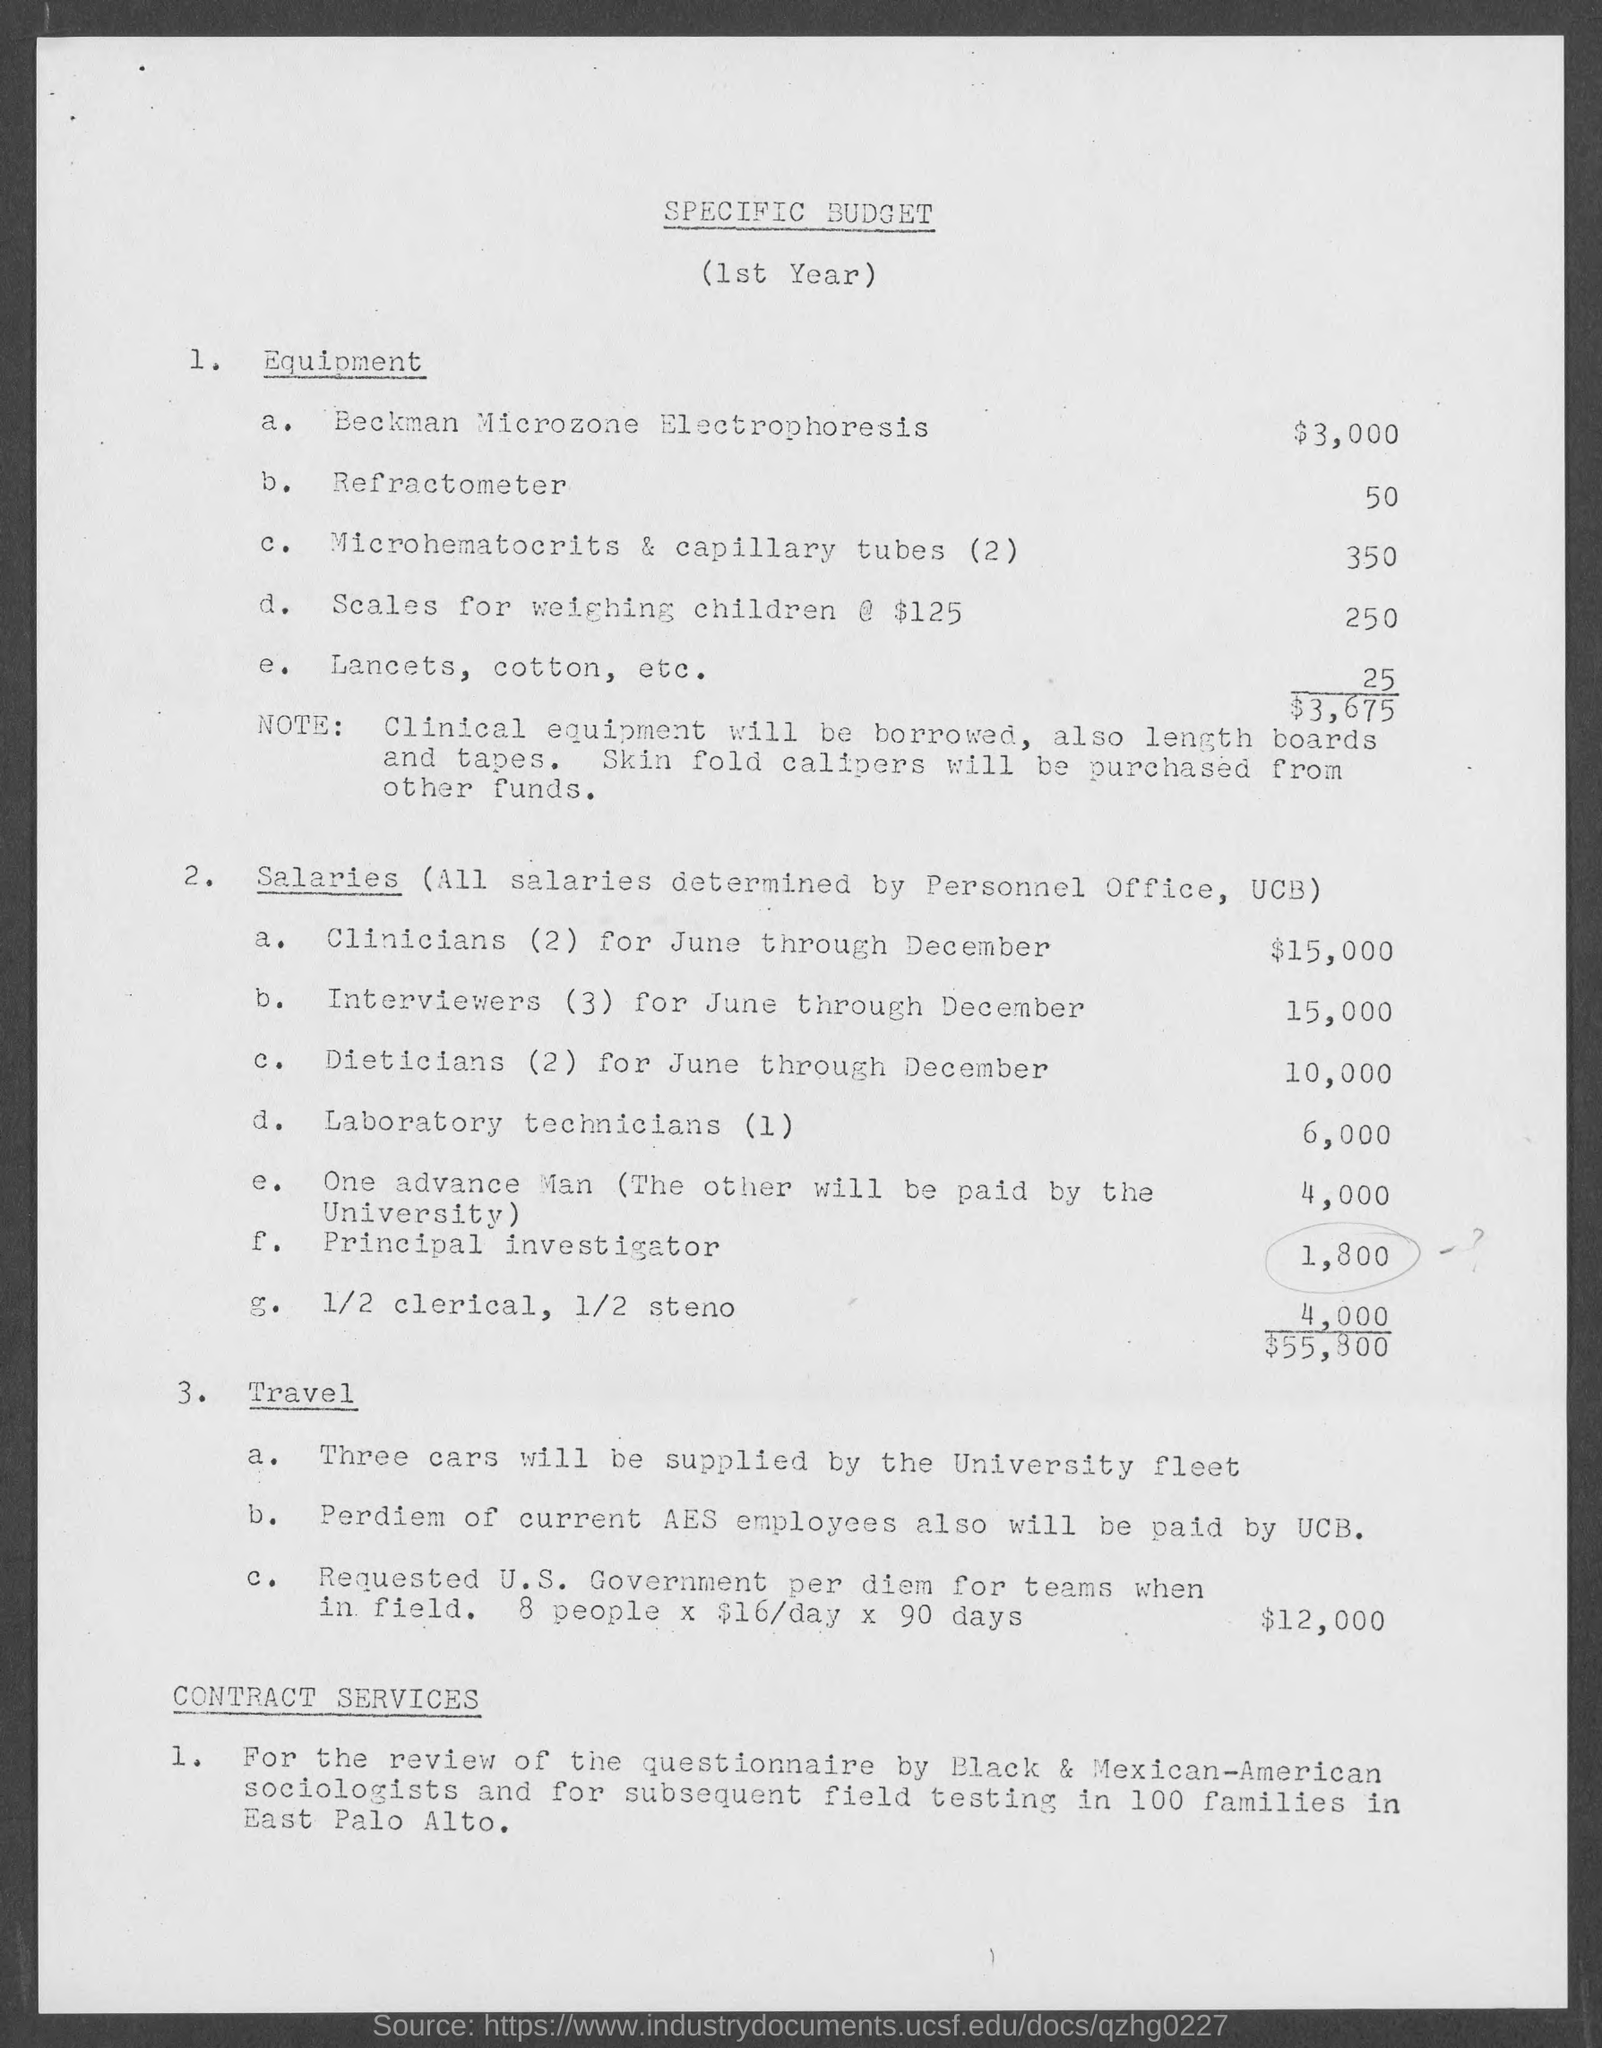What is the Title of the document?
Ensure brevity in your answer.  Specific Budget. What is the Cost for Beckman Microzone Electrophoresis?
Your response must be concise. $3,000. What is the Cost for Refractometer?
Ensure brevity in your answer.  50. What is the Cost for Microhematocrits & capillary tubes (2)?
Provide a succinct answer. 350. What is the Cost for Scales for weighing children?
Give a very brief answer. 250. 